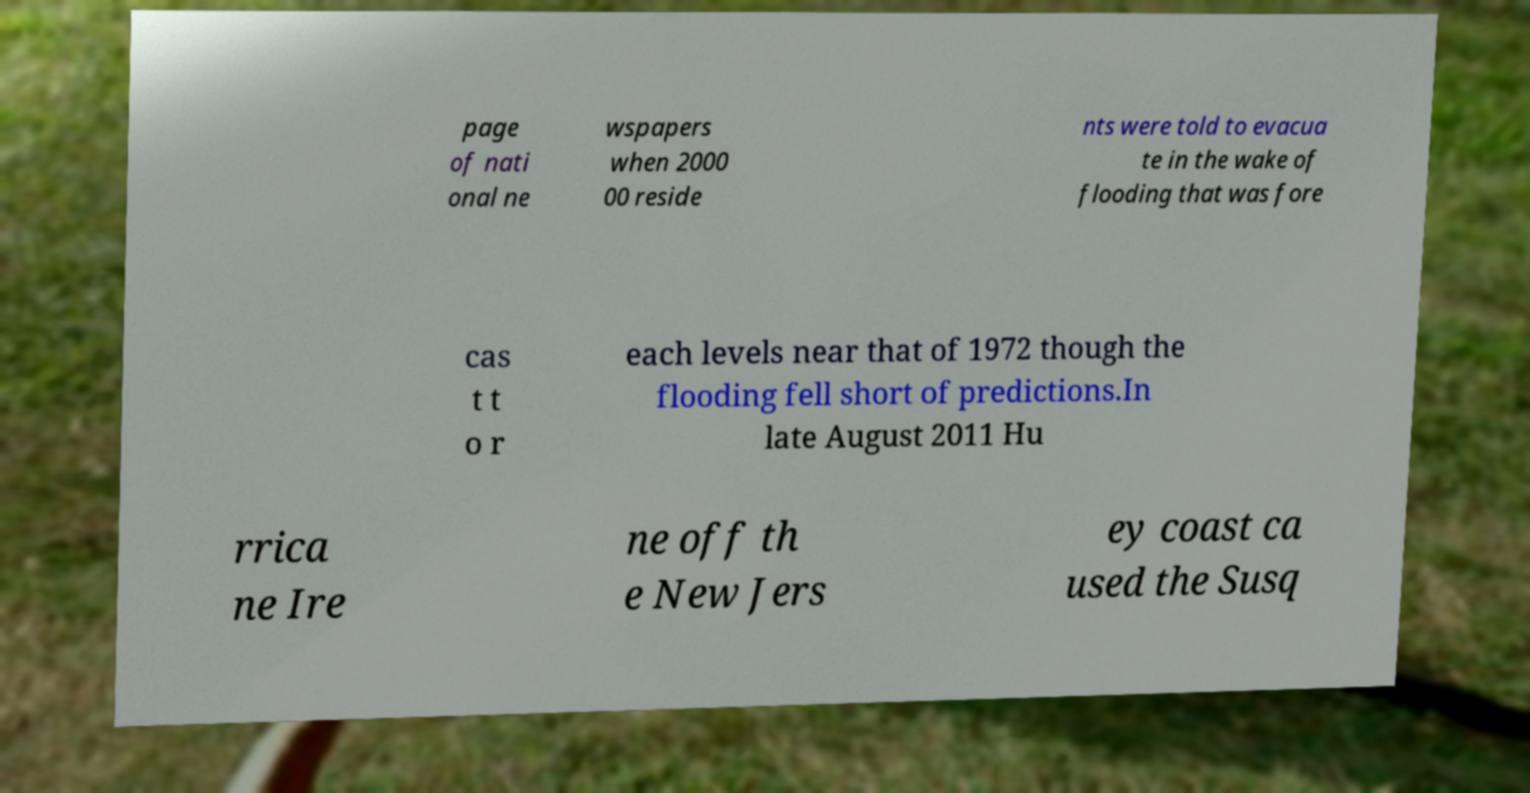Please read and relay the text visible in this image. What does it say? page of nati onal ne wspapers when 2000 00 reside nts were told to evacua te in the wake of flooding that was fore cas t t o r each levels near that of 1972 though the flooding fell short of predictions.In late August 2011 Hu rrica ne Ire ne off th e New Jers ey coast ca used the Susq 